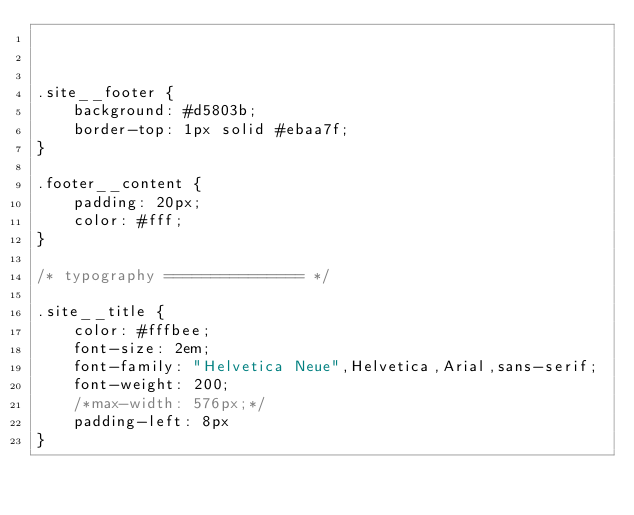Convert code to text. <code><loc_0><loc_0><loc_500><loc_500><_CSS_>


.site__footer {
	background: #d5803b;
	border-top: 1px solid #ebaa7f;
}

.footer__content {
	padding: 20px;
	color: #fff;
}

/* typography =============== */

.site__title {
	color: #fffbee;
	font-size: 2em;
	font-family: "Helvetica Neue",Helvetica,Arial,sans-serif;
	font-weight: 200;
	/*max-width: 576px;*/
	padding-left: 8px
}
</code> 